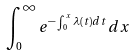Convert formula to latex. <formula><loc_0><loc_0><loc_500><loc_500>\int _ { 0 } ^ { \infty } e ^ { - \int _ { 0 } ^ { x } \lambda ( t ) d t } d x</formula> 